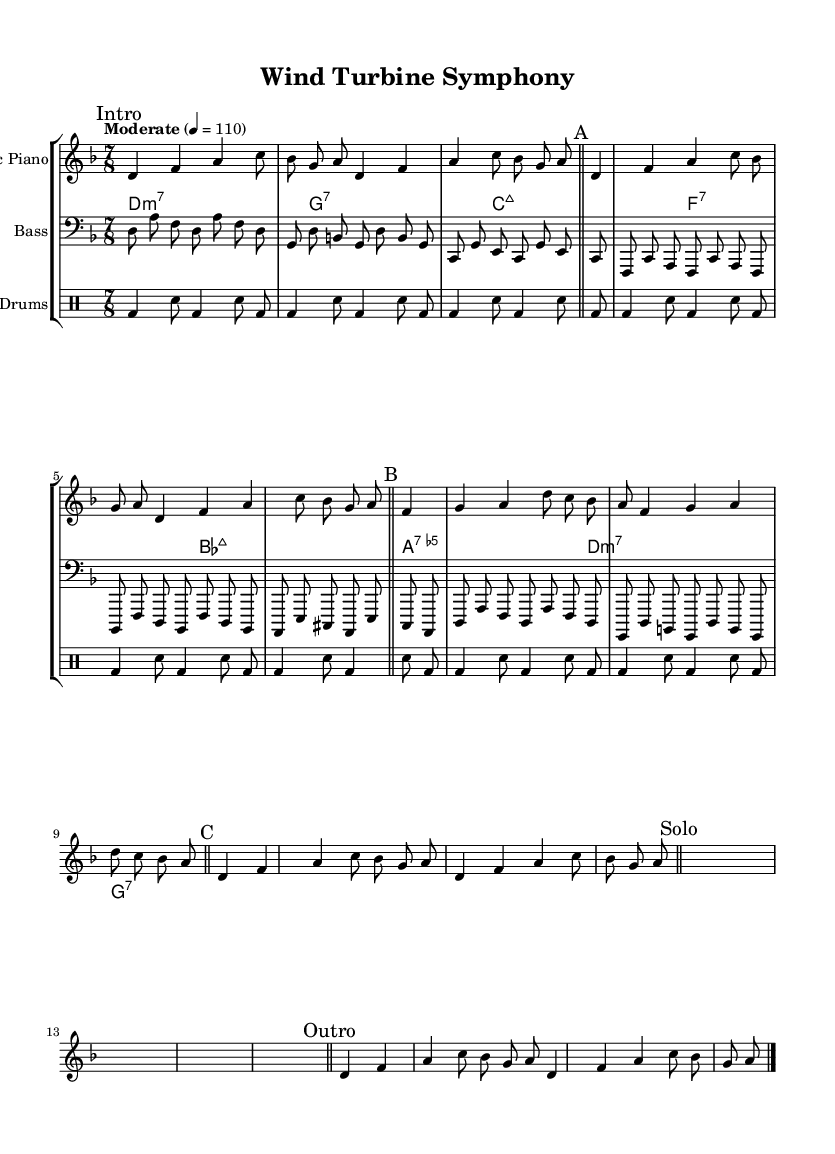What is the key signature of this music? The key signature is indicated at the beginning of the staff, showing one flat, which corresponds to D minor.
Answer: D minor What is the time signature of this music? The time signature is shown at the beginning of the staff and is written as 7/8, meaning there are seven eighth notes in a measure.
Answer: 7/8 What is the tempo marking of this music? The tempo is indicated above the staff as "Moderate" with the metronome marking of 4 equals 110, which gives a sense of speed.
Answer: Moderate 4 = 110 How many measures are in the 'Intro' section? The 'Intro' section begins with a mark and contains two measures before the first double bar, concluding that there are two measures.
Answer: 2 In which section does the solo occur? The solo section is explicitly marked as "Solo" in the score, which helps to identify the part where improvisation typically occurs in jazz.
Answer: Solo How many chord changes occur in section 'B'? Section 'B' is identified and contains two measures with a repeated chord pattern; counting the chords reveals there are four chords in this section.
Answer: 4 What instruments are featured in this composition? The score includes three distinct instrument staffs: Electric Piano, Bass, and Drums, indicating all the performers required for this piece.
Answer: Electric Piano, Bass, Drums 